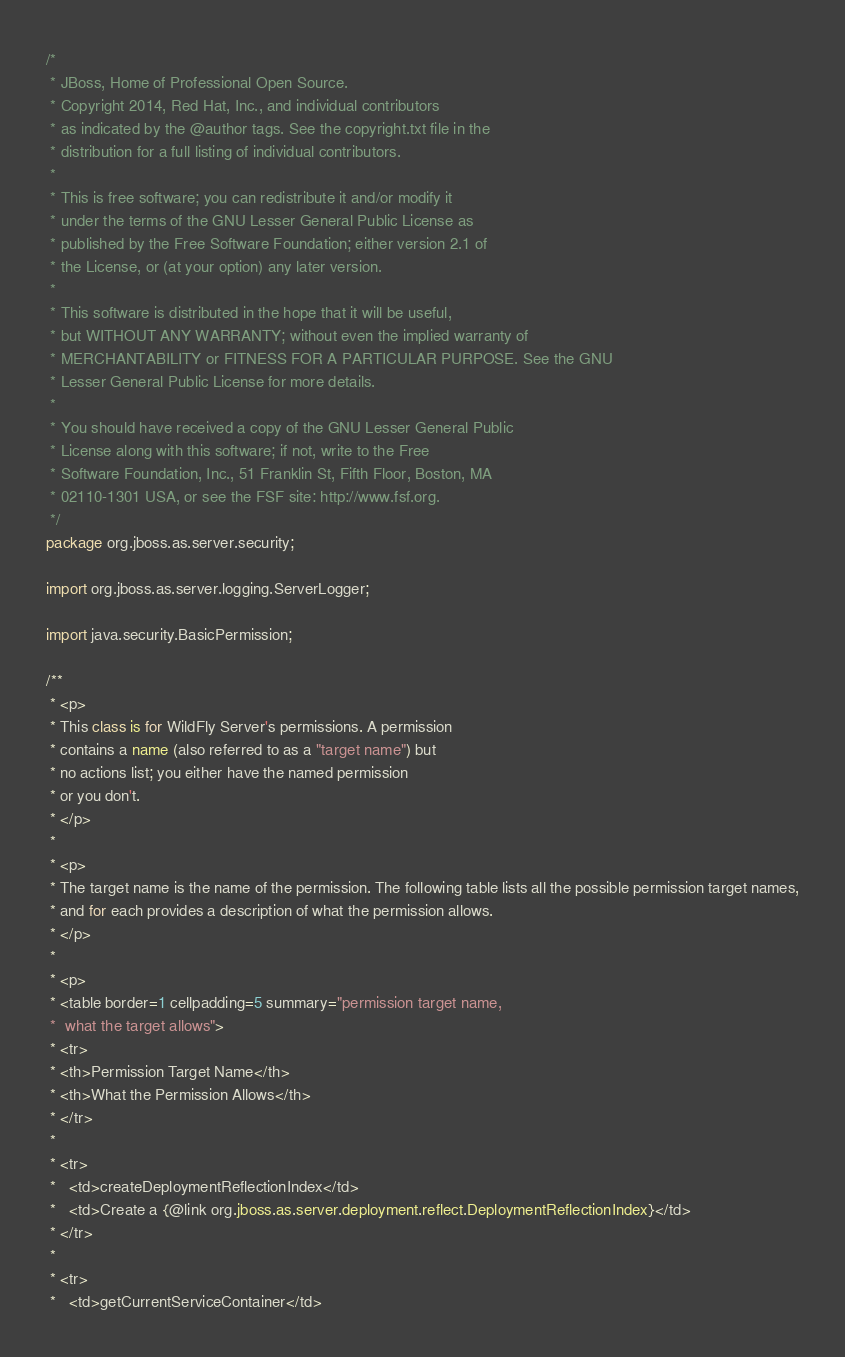<code> <loc_0><loc_0><loc_500><loc_500><_Java_>/*
 * JBoss, Home of Professional Open Source.
 * Copyright 2014, Red Hat, Inc., and individual contributors
 * as indicated by the @author tags. See the copyright.txt file in the
 * distribution for a full listing of individual contributors.
 *
 * This is free software; you can redistribute it and/or modify it
 * under the terms of the GNU Lesser General Public License as
 * published by the Free Software Foundation; either version 2.1 of
 * the License, or (at your option) any later version.
 *
 * This software is distributed in the hope that it will be useful,
 * but WITHOUT ANY WARRANTY; without even the implied warranty of
 * MERCHANTABILITY or FITNESS FOR A PARTICULAR PURPOSE. See the GNU
 * Lesser General Public License for more details.
 *
 * You should have received a copy of the GNU Lesser General Public
 * License along with this software; if not, write to the Free
 * Software Foundation, Inc., 51 Franklin St, Fifth Floor, Boston, MA
 * 02110-1301 USA, or see the FSF site: http://www.fsf.org.
 */
package org.jboss.as.server.security;

import org.jboss.as.server.logging.ServerLogger;

import java.security.BasicPermission;

/**
 * <p>
 * This class is for WildFly Server's permissions. A permission
 * contains a name (also referred to as a "target name") but
 * no actions list; you either have the named permission
 * or you don't.
 * </p>
 *
 * <p>
 * The target name is the name of the permission. The following table lists all the possible permission target names,
 * and for each provides a description of what the permission allows.
 * </p>
 *
 * <p>
 * <table border=1 cellpadding=5 summary="permission target name,
 *  what the target allows">
 * <tr>
 * <th>Permission Target Name</th>
 * <th>What the Permission Allows</th>
 * </tr>
 *
 * <tr>
 *   <td>createDeploymentReflectionIndex</td>
 *   <td>Create a {@link org.jboss.as.server.deployment.reflect.DeploymentReflectionIndex}</td>
 * </tr>
 *
 * <tr>
 *   <td>getCurrentServiceContainer</td></code> 